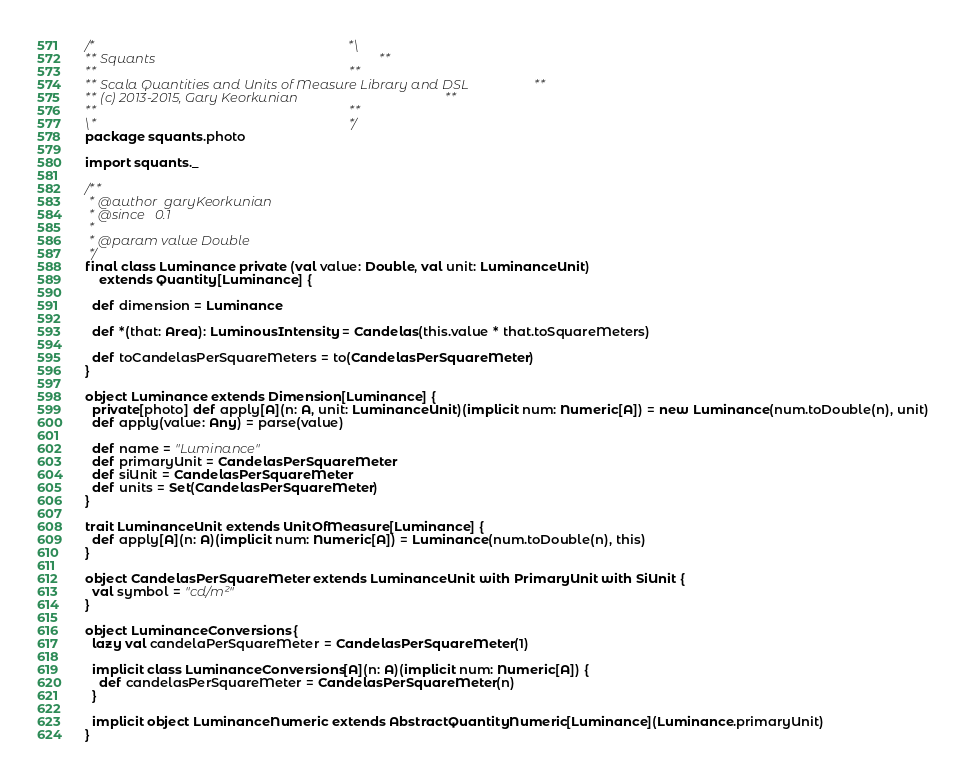Convert code to text. <code><loc_0><loc_0><loc_500><loc_500><_Scala_>/*                                                                      *\
** Squants                                                              **
**                                                                      **
** Scala Quantities and Units of Measure Library and DSL                **
** (c) 2013-2015, Gary Keorkunian                                       **
**                                                                      **
\*                                                                      */
package squants.photo

import squants._

/**
 * @author  garyKeorkunian
 * @since   0.1
 *
 * @param value Double
 */
final class Luminance private (val value: Double, val unit: LuminanceUnit)
    extends Quantity[Luminance] {

  def dimension = Luminance

  def *(that: Area): LuminousIntensity = Candelas(this.value * that.toSquareMeters)

  def toCandelasPerSquareMeters = to(CandelasPerSquareMeter)
}

object Luminance extends Dimension[Luminance] {
  private[photo] def apply[A](n: A, unit: LuminanceUnit)(implicit num: Numeric[A]) = new Luminance(num.toDouble(n), unit)
  def apply(value: Any) = parse(value)

  def name = "Luminance"
  def primaryUnit = CandelasPerSquareMeter
  def siUnit = CandelasPerSquareMeter
  def units = Set(CandelasPerSquareMeter)
}

trait LuminanceUnit extends UnitOfMeasure[Luminance] {
  def apply[A](n: A)(implicit num: Numeric[A]) = Luminance(num.toDouble(n), this)
}

object CandelasPerSquareMeter extends LuminanceUnit with PrimaryUnit with SiUnit {
  val symbol = "cd/m²"
}

object LuminanceConversions {
  lazy val candelaPerSquareMeter = CandelasPerSquareMeter(1)

  implicit class LuminanceConversions[A](n: A)(implicit num: Numeric[A]) {
    def candelasPerSquareMeter = CandelasPerSquareMeter(n)
  }

  implicit object LuminanceNumeric extends AbstractQuantityNumeric[Luminance](Luminance.primaryUnit)
}

</code> 